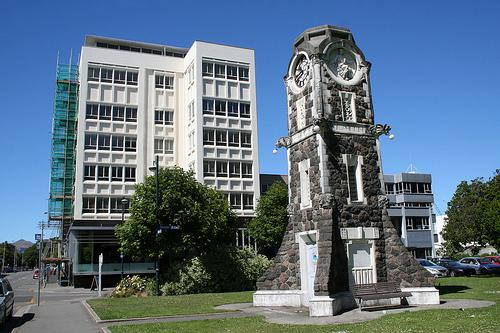Question: what is the color of the tall building?
Choices:
A. Black.
B. Pink.
C. White.
D. Grey.
Answer with the letter. Answer: C Question: what is the color of the trees?
Choices:
A. Orange.
B. Yellow.
C. Green.
D. Red.
Answer with the letter. Answer: C Question: why are the cars in the picture?
Choices:
A. Are parked.
B. Transportation.
C. Decoration.
D. Car show.
Answer with the letter. Answer: A Question: how many street lights can you see?
Choices:
A. One.
B. Three.
C. Two.
D. Four.
Answer with the letter. Answer: C Question: how cars can you see in the picture?
Choices:
A. 10.
B. 11.
C. 15.
D. 6.
Answer with the letter. Answer: D 